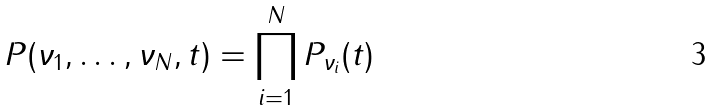<formula> <loc_0><loc_0><loc_500><loc_500>P ( \nu _ { 1 } , \dots , \nu _ { N } , t ) = \prod _ { i = 1 } ^ { N } P _ { \nu _ { i } } ( t )</formula> 